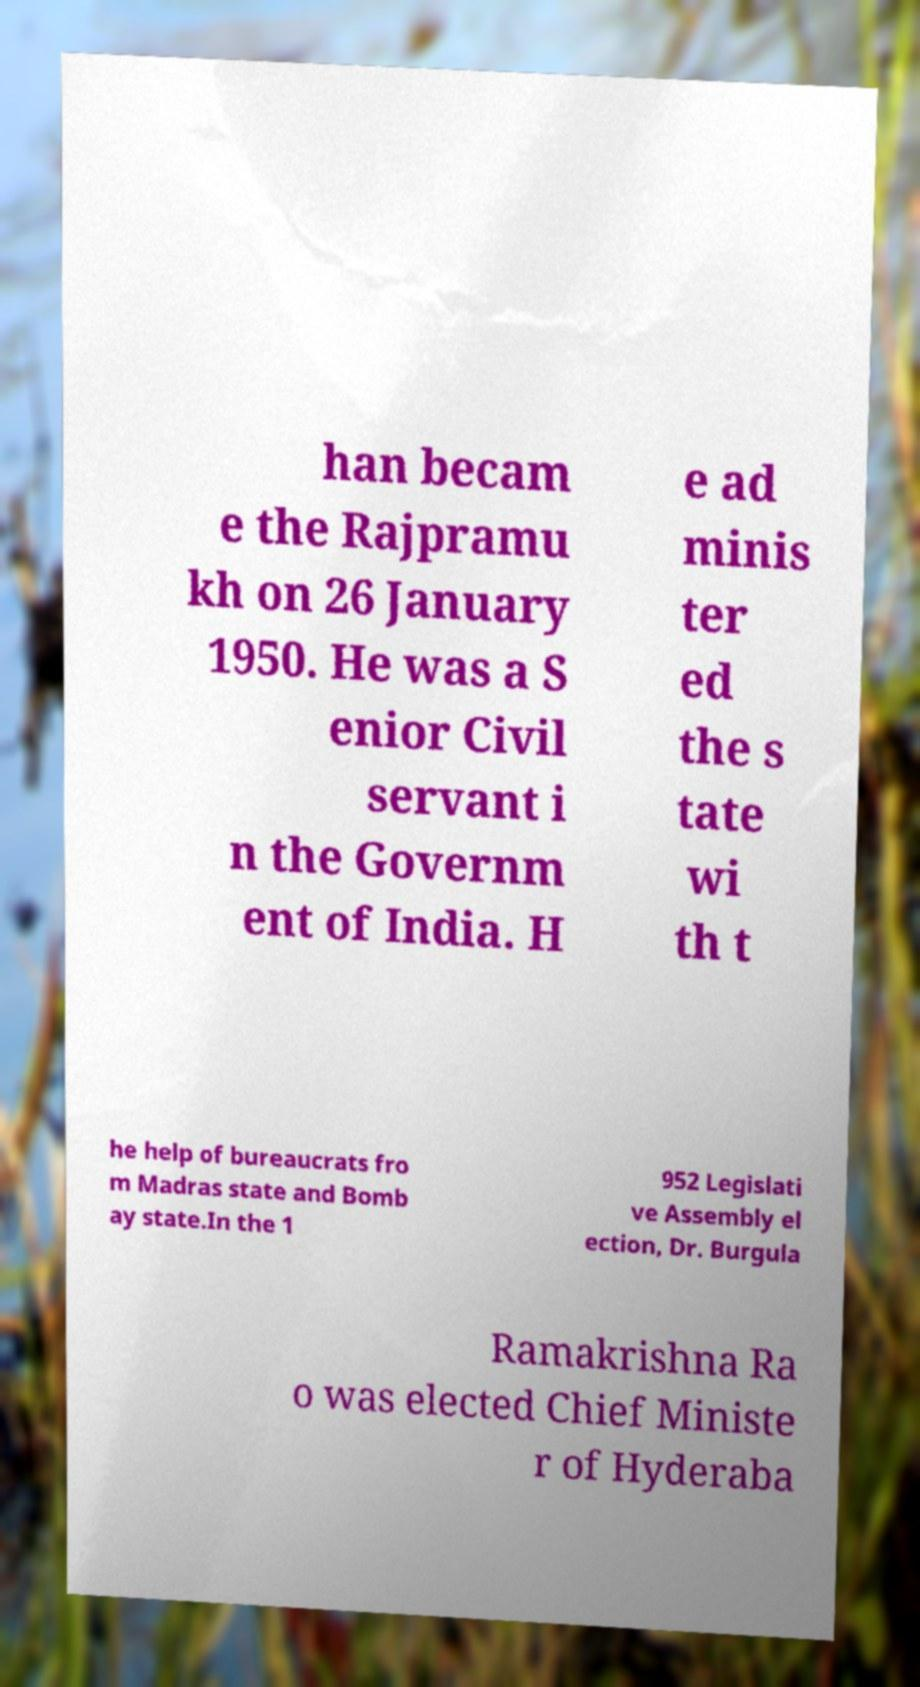What messages or text are displayed in this image? I need them in a readable, typed format. han becam e the Rajpramu kh on 26 January 1950. He was a S enior Civil servant i n the Governm ent of India. H e ad minis ter ed the s tate wi th t he help of bureaucrats fro m Madras state and Bomb ay state.In the 1 952 Legislati ve Assembly el ection, Dr. Burgula Ramakrishna Ra o was elected Chief Ministe r of Hyderaba 